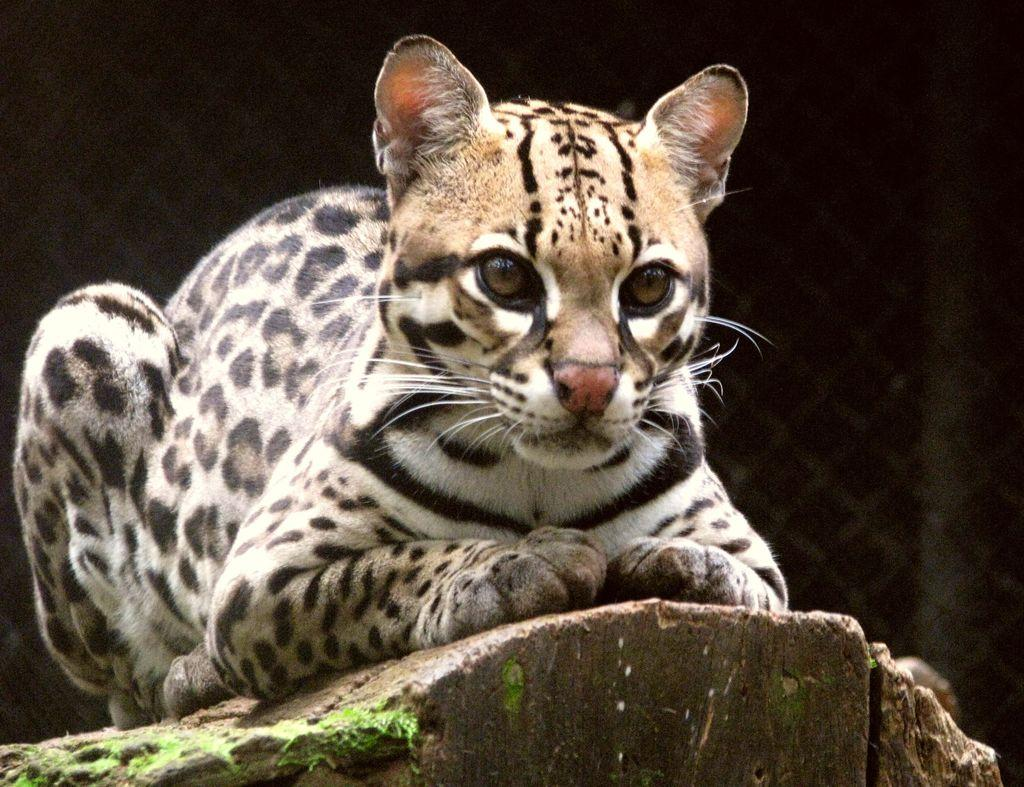What type of animal is in the picture? The type of animal cannot be determined from the provided facts. Where is the animal located in the picture? The animal is sitting on a rock in the picture. What can be seen in the background of the picture? There is a fence in the background of the picture. How would you describe the lighting in the image? The image appears to be a bit dark. What type of corn is growing in the front of the image? There is no corn present in the image. What type of crime is being committed in the image? There is no crime being committed in the image. 